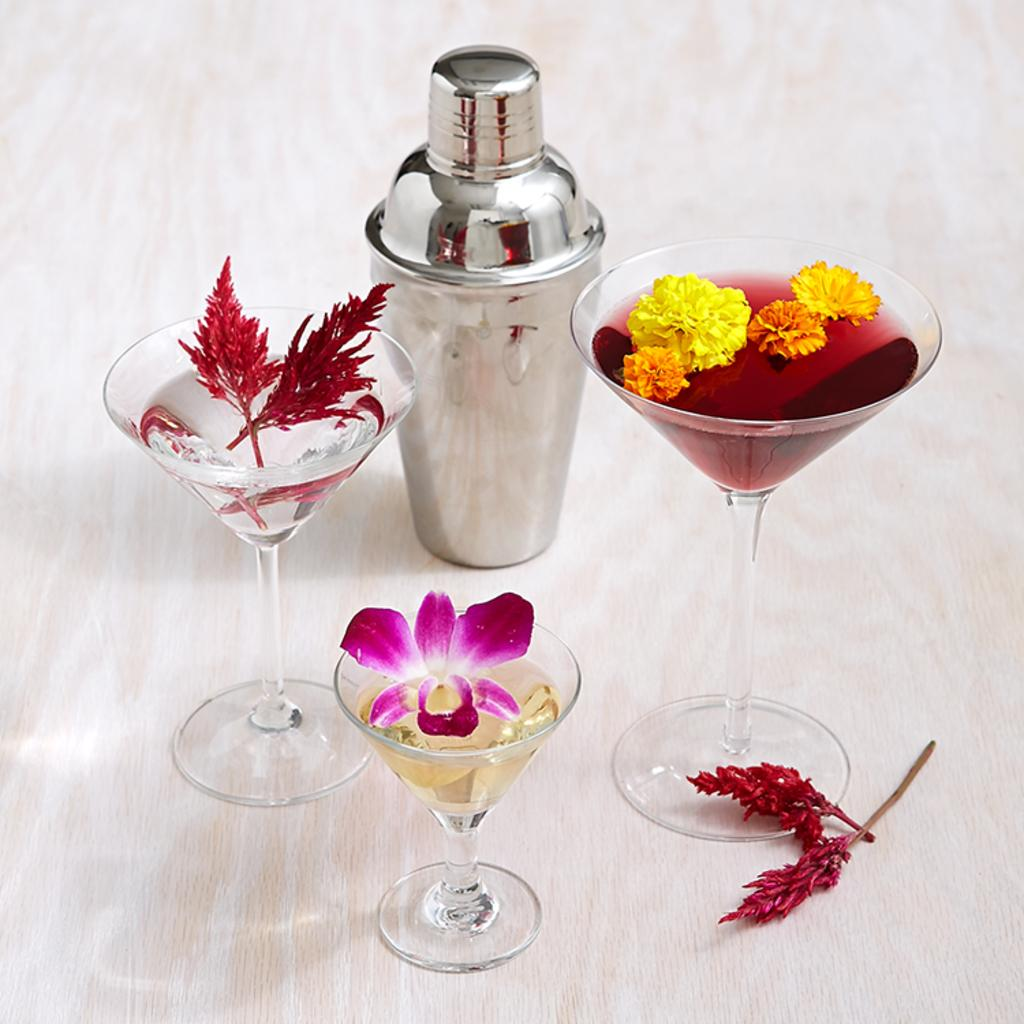What objects are on the surface in the image? There are glasses on the surface in the image. What is inside the glasses? There is a drink inside the glasses. What type of decoration or natural element is present in the image? There are flowers in the image. What else can be seen on the surface besides the glasses? There are objects on the surface in the image. What order are the glasses arranged in the image? The provided facts do not give us enough information to determine the order in which the glasses are arranged. --- 